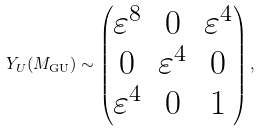<formula> <loc_0><loc_0><loc_500><loc_500>Y _ { U } ( M _ { \text {GU} } ) \sim \begin{pmatrix} \varepsilon ^ { 8 } & 0 & \varepsilon ^ { 4 } \\ 0 & \varepsilon ^ { 4 } & 0 \\ \varepsilon ^ { 4 } & 0 & 1 \end{pmatrix} ,</formula> 